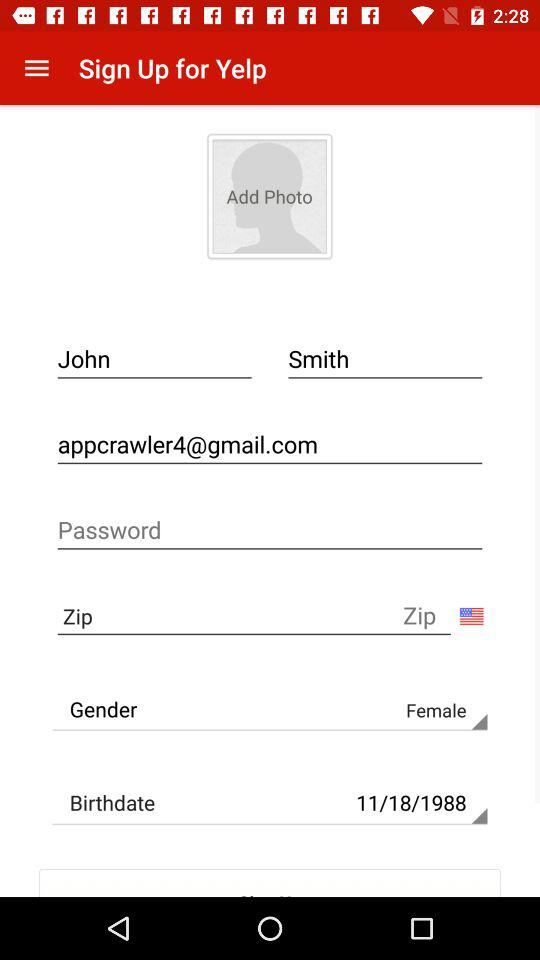What's the user name? The user name is John Smith. 